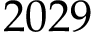Convert formula to latex. <formula><loc_0><loc_0><loc_500><loc_500>2 0 2 9</formula> 